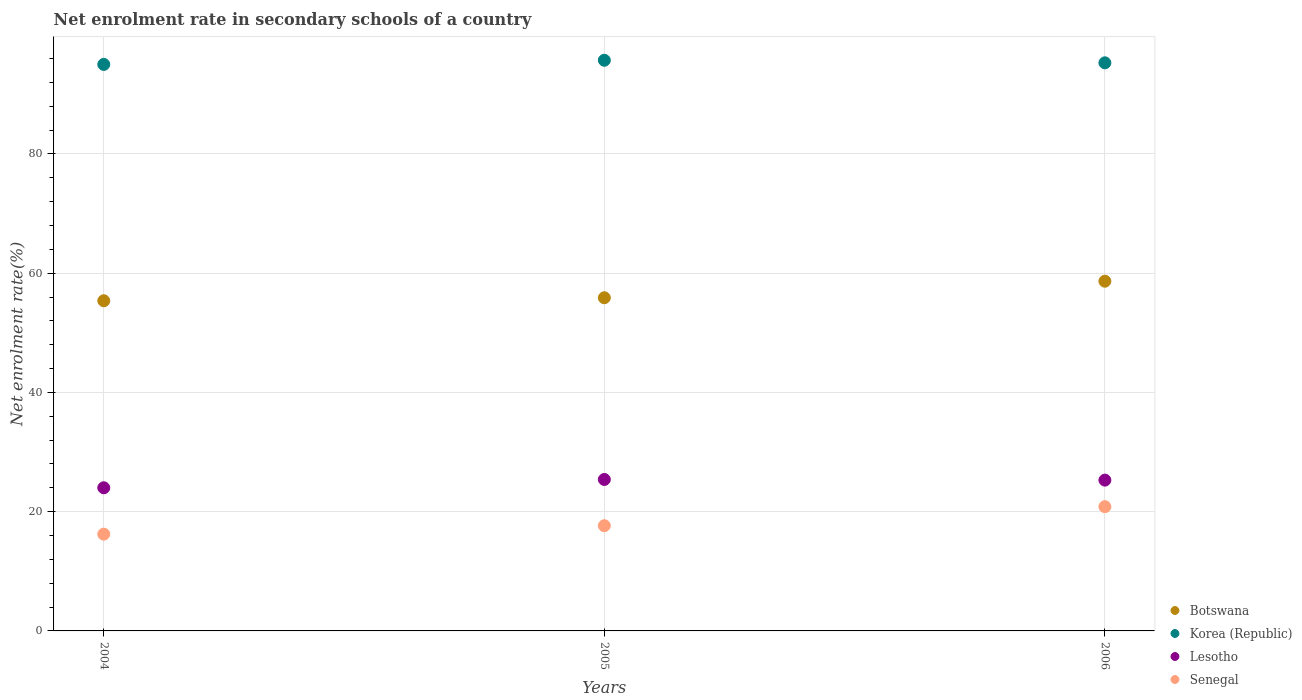How many different coloured dotlines are there?
Provide a succinct answer. 4. What is the net enrolment rate in secondary schools in Korea (Republic) in 2006?
Provide a succinct answer. 95.28. Across all years, what is the maximum net enrolment rate in secondary schools in Lesotho?
Keep it short and to the point. 25.4. Across all years, what is the minimum net enrolment rate in secondary schools in Botswana?
Your answer should be very brief. 55.38. In which year was the net enrolment rate in secondary schools in Senegal maximum?
Provide a succinct answer. 2006. What is the total net enrolment rate in secondary schools in Botswana in the graph?
Make the answer very short. 169.91. What is the difference between the net enrolment rate in secondary schools in Korea (Republic) in 2004 and that in 2005?
Your answer should be very brief. -0.7. What is the difference between the net enrolment rate in secondary schools in Botswana in 2006 and the net enrolment rate in secondary schools in Korea (Republic) in 2004?
Ensure brevity in your answer.  -36.36. What is the average net enrolment rate in secondary schools in Korea (Republic) per year?
Make the answer very short. 95.34. In the year 2004, what is the difference between the net enrolment rate in secondary schools in Lesotho and net enrolment rate in secondary schools in Botswana?
Provide a short and direct response. -31.37. What is the ratio of the net enrolment rate in secondary schools in Senegal in 2005 to that in 2006?
Your answer should be compact. 0.85. What is the difference between the highest and the second highest net enrolment rate in secondary schools in Senegal?
Give a very brief answer. 3.19. What is the difference between the highest and the lowest net enrolment rate in secondary schools in Botswana?
Make the answer very short. 3.28. Does the net enrolment rate in secondary schools in Botswana monotonically increase over the years?
Your response must be concise. Yes. Is the net enrolment rate in secondary schools in Senegal strictly less than the net enrolment rate in secondary schools in Lesotho over the years?
Provide a succinct answer. Yes. How many years are there in the graph?
Offer a terse response. 3. Are the values on the major ticks of Y-axis written in scientific E-notation?
Provide a short and direct response. No. How many legend labels are there?
Offer a very short reply. 4. How are the legend labels stacked?
Your answer should be very brief. Vertical. What is the title of the graph?
Your response must be concise. Net enrolment rate in secondary schools of a country. Does "Rwanda" appear as one of the legend labels in the graph?
Ensure brevity in your answer.  No. What is the label or title of the X-axis?
Your answer should be compact. Years. What is the label or title of the Y-axis?
Offer a very short reply. Net enrolment rate(%). What is the Net enrolment rate(%) in Botswana in 2004?
Your response must be concise. 55.38. What is the Net enrolment rate(%) of Korea (Republic) in 2004?
Give a very brief answer. 95.02. What is the Net enrolment rate(%) of Lesotho in 2004?
Your response must be concise. 24.01. What is the Net enrolment rate(%) in Senegal in 2004?
Make the answer very short. 16.23. What is the Net enrolment rate(%) in Botswana in 2005?
Keep it short and to the point. 55.88. What is the Net enrolment rate(%) of Korea (Republic) in 2005?
Provide a succinct answer. 95.71. What is the Net enrolment rate(%) in Lesotho in 2005?
Keep it short and to the point. 25.4. What is the Net enrolment rate(%) of Senegal in 2005?
Keep it short and to the point. 17.65. What is the Net enrolment rate(%) of Botswana in 2006?
Give a very brief answer. 58.66. What is the Net enrolment rate(%) of Korea (Republic) in 2006?
Offer a very short reply. 95.28. What is the Net enrolment rate(%) of Lesotho in 2006?
Keep it short and to the point. 25.29. What is the Net enrolment rate(%) of Senegal in 2006?
Give a very brief answer. 20.84. Across all years, what is the maximum Net enrolment rate(%) in Botswana?
Your response must be concise. 58.66. Across all years, what is the maximum Net enrolment rate(%) in Korea (Republic)?
Keep it short and to the point. 95.71. Across all years, what is the maximum Net enrolment rate(%) in Lesotho?
Provide a succinct answer. 25.4. Across all years, what is the maximum Net enrolment rate(%) in Senegal?
Make the answer very short. 20.84. Across all years, what is the minimum Net enrolment rate(%) of Botswana?
Make the answer very short. 55.38. Across all years, what is the minimum Net enrolment rate(%) in Korea (Republic)?
Offer a very short reply. 95.02. Across all years, what is the minimum Net enrolment rate(%) in Lesotho?
Ensure brevity in your answer.  24.01. Across all years, what is the minimum Net enrolment rate(%) of Senegal?
Provide a succinct answer. 16.23. What is the total Net enrolment rate(%) in Botswana in the graph?
Ensure brevity in your answer.  169.91. What is the total Net enrolment rate(%) in Korea (Republic) in the graph?
Offer a very short reply. 286.01. What is the total Net enrolment rate(%) of Lesotho in the graph?
Your answer should be compact. 74.71. What is the total Net enrolment rate(%) in Senegal in the graph?
Provide a short and direct response. 54.72. What is the difference between the Net enrolment rate(%) in Botswana in 2004 and that in 2005?
Provide a short and direct response. -0.5. What is the difference between the Net enrolment rate(%) in Korea (Republic) in 2004 and that in 2005?
Your answer should be compact. -0.7. What is the difference between the Net enrolment rate(%) in Lesotho in 2004 and that in 2005?
Your answer should be very brief. -1.39. What is the difference between the Net enrolment rate(%) in Senegal in 2004 and that in 2005?
Provide a short and direct response. -1.42. What is the difference between the Net enrolment rate(%) in Botswana in 2004 and that in 2006?
Your answer should be very brief. -3.28. What is the difference between the Net enrolment rate(%) in Korea (Republic) in 2004 and that in 2006?
Provide a succinct answer. -0.27. What is the difference between the Net enrolment rate(%) of Lesotho in 2004 and that in 2006?
Keep it short and to the point. -1.28. What is the difference between the Net enrolment rate(%) of Senegal in 2004 and that in 2006?
Ensure brevity in your answer.  -4.61. What is the difference between the Net enrolment rate(%) of Botswana in 2005 and that in 2006?
Your answer should be very brief. -2.77. What is the difference between the Net enrolment rate(%) in Korea (Republic) in 2005 and that in 2006?
Provide a succinct answer. 0.43. What is the difference between the Net enrolment rate(%) in Lesotho in 2005 and that in 2006?
Offer a terse response. 0.11. What is the difference between the Net enrolment rate(%) of Senegal in 2005 and that in 2006?
Offer a terse response. -3.19. What is the difference between the Net enrolment rate(%) in Botswana in 2004 and the Net enrolment rate(%) in Korea (Republic) in 2005?
Ensure brevity in your answer.  -40.34. What is the difference between the Net enrolment rate(%) of Botswana in 2004 and the Net enrolment rate(%) of Lesotho in 2005?
Your answer should be compact. 29.97. What is the difference between the Net enrolment rate(%) of Botswana in 2004 and the Net enrolment rate(%) of Senegal in 2005?
Provide a short and direct response. 37.73. What is the difference between the Net enrolment rate(%) in Korea (Republic) in 2004 and the Net enrolment rate(%) in Lesotho in 2005?
Provide a succinct answer. 69.61. What is the difference between the Net enrolment rate(%) in Korea (Republic) in 2004 and the Net enrolment rate(%) in Senegal in 2005?
Offer a terse response. 77.37. What is the difference between the Net enrolment rate(%) of Lesotho in 2004 and the Net enrolment rate(%) of Senegal in 2005?
Your answer should be compact. 6.36. What is the difference between the Net enrolment rate(%) of Botswana in 2004 and the Net enrolment rate(%) of Korea (Republic) in 2006?
Provide a succinct answer. -39.9. What is the difference between the Net enrolment rate(%) in Botswana in 2004 and the Net enrolment rate(%) in Lesotho in 2006?
Offer a very short reply. 30.08. What is the difference between the Net enrolment rate(%) in Botswana in 2004 and the Net enrolment rate(%) in Senegal in 2006?
Keep it short and to the point. 34.54. What is the difference between the Net enrolment rate(%) of Korea (Republic) in 2004 and the Net enrolment rate(%) of Lesotho in 2006?
Provide a short and direct response. 69.72. What is the difference between the Net enrolment rate(%) of Korea (Republic) in 2004 and the Net enrolment rate(%) of Senegal in 2006?
Your answer should be very brief. 74.18. What is the difference between the Net enrolment rate(%) of Lesotho in 2004 and the Net enrolment rate(%) of Senegal in 2006?
Keep it short and to the point. 3.17. What is the difference between the Net enrolment rate(%) of Botswana in 2005 and the Net enrolment rate(%) of Korea (Republic) in 2006?
Make the answer very short. -39.4. What is the difference between the Net enrolment rate(%) in Botswana in 2005 and the Net enrolment rate(%) in Lesotho in 2006?
Provide a short and direct response. 30.59. What is the difference between the Net enrolment rate(%) in Botswana in 2005 and the Net enrolment rate(%) in Senegal in 2006?
Your response must be concise. 35.04. What is the difference between the Net enrolment rate(%) of Korea (Republic) in 2005 and the Net enrolment rate(%) of Lesotho in 2006?
Provide a succinct answer. 70.42. What is the difference between the Net enrolment rate(%) in Korea (Republic) in 2005 and the Net enrolment rate(%) in Senegal in 2006?
Ensure brevity in your answer.  74.87. What is the difference between the Net enrolment rate(%) in Lesotho in 2005 and the Net enrolment rate(%) in Senegal in 2006?
Your response must be concise. 4.56. What is the average Net enrolment rate(%) of Botswana per year?
Offer a very short reply. 56.64. What is the average Net enrolment rate(%) in Korea (Republic) per year?
Your answer should be very brief. 95.34. What is the average Net enrolment rate(%) of Lesotho per year?
Give a very brief answer. 24.9. What is the average Net enrolment rate(%) in Senegal per year?
Make the answer very short. 18.24. In the year 2004, what is the difference between the Net enrolment rate(%) of Botswana and Net enrolment rate(%) of Korea (Republic)?
Provide a short and direct response. -39.64. In the year 2004, what is the difference between the Net enrolment rate(%) in Botswana and Net enrolment rate(%) in Lesotho?
Offer a very short reply. 31.37. In the year 2004, what is the difference between the Net enrolment rate(%) in Botswana and Net enrolment rate(%) in Senegal?
Offer a very short reply. 39.15. In the year 2004, what is the difference between the Net enrolment rate(%) of Korea (Republic) and Net enrolment rate(%) of Lesotho?
Make the answer very short. 71.01. In the year 2004, what is the difference between the Net enrolment rate(%) of Korea (Republic) and Net enrolment rate(%) of Senegal?
Offer a terse response. 78.79. In the year 2004, what is the difference between the Net enrolment rate(%) of Lesotho and Net enrolment rate(%) of Senegal?
Your answer should be very brief. 7.78. In the year 2005, what is the difference between the Net enrolment rate(%) of Botswana and Net enrolment rate(%) of Korea (Republic)?
Offer a terse response. -39.83. In the year 2005, what is the difference between the Net enrolment rate(%) of Botswana and Net enrolment rate(%) of Lesotho?
Your answer should be compact. 30.48. In the year 2005, what is the difference between the Net enrolment rate(%) of Botswana and Net enrolment rate(%) of Senegal?
Provide a succinct answer. 38.23. In the year 2005, what is the difference between the Net enrolment rate(%) in Korea (Republic) and Net enrolment rate(%) in Lesotho?
Your answer should be very brief. 70.31. In the year 2005, what is the difference between the Net enrolment rate(%) in Korea (Republic) and Net enrolment rate(%) in Senegal?
Your answer should be compact. 78.06. In the year 2005, what is the difference between the Net enrolment rate(%) of Lesotho and Net enrolment rate(%) of Senegal?
Give a very brief answer. 7.75. In the year 2006, what is the difference between the Net enrolment rate(%) in Botswana and Net enrolment rate(%) in Korea (Republic)?
Your answer should be very brief. -36.63. In the year 2006, what is the difference between the Net enrolment rate(%) of Botswana and Net enrolment rate(%) of Lesotho?
Your response must be concise. 33.36. In the year 2006, what is the difference between the Net enrolment rate(%) of Botswana and Net enrolment rate(%) of Senegal?
Provide a succinct answer. 37.81. In the year 2006, what is the difference between the Net enrolment rate(%) of Korea (Republic) and Net enrolment rate(%) of Lesotho?
Give a very brief answer. 69.99. In the year 2006, what is the difference between the Net enrolment rate(%) of Korea (Republic) and Net enrolment rate(%) of Senegal?
Keep it short and to the point. 74.44. In the year 2006, what is the difference between the Net enrolment rate(%) in Lesotho and Net enrolment rate(%) in Senegal?
Offer a terse response. 4.45. What is the ratio of the Net enrolment rate(%) in Botswana in 2004 to that in 2005?
Ensure brevity in your answer.  0.99. What is the ratio of the Net enrolment rate(%) of Lesotho in 2004 to that in 2005?
Keep it short and to the point. 0.95. What is the ratio of the Net enrolment rate(%) in Senegal in 2004 to that in 2005?
Keep it short and to the point. 0.92. What is the ratio of the Net enrolment rate(%) in Botswana in 2004 to that in 2006?
Provide a succinct answer. 0.94. What is the ratio of the Net enrolment rate(%) of Korea (Republic) in 2004 to that in 2006?
Make the answer very short. 1. What is the ratio of the Net enrolment rate(%) of Lesotho in 2004 to that in 2006?
Ensure brevity in your answer.  0.95. What is the ratio of the Net enrolment rate(%) of Senegal in 2004 to that in 2006?
Ensure brevity in your answer.  0.78. What is the ratio of the Net enrolment rate(%) of Botswana in 2005 to that in 2006?
Give a very brief answer. 0.95. What is the ratio of the Net enrolment rate(%) in Korea (Republic) in 2005 to that in 2006?
Offer a very short reply. 1. What is the ratio of the Net enrolment rate(%) in Lesotho in 2005 to that in 2006?
Provide a succinct answer. 1. What is the ratio of the Net enrolment rate(%) in Senegal in 2005 to that in 2006?
Ensure brevity in your answer.  0.85. What is the difference between the highest and the second highest Net enrolment rate(%) in Botswana?
Make the answer very short. 2.77. What is the difference between the highest and the second highest Net enrolment rate(%) of Korea (Republic)?
Your response must be concise. 0.43. What is the difference between the highest and the second highest Net enrolment rate(%) of Lesotho?
Offer a very short reply. 0.11. What is the difference between the highest and the second highest Net enrolment rate(%) in Senegal?
Offer a very short reply. 3.19. What is the difference between the highest and the lowest Net enrolment rate(%) in Botswana?
Give a very brief answer. 3.28. What is the difference between the highest and the lowest Net enrolment rate(%) in Korea (Republic)?
Your answer should be very brief. 0.7. What is the difference between the highest and the lowest Net enrolment rate(%) in Lesotho?
Make the answer very short. 1.39. What is the difference between the highest and the lowest Net enrolment rate(%) in Senegal?
Keep it short and to the point. 4.61. 